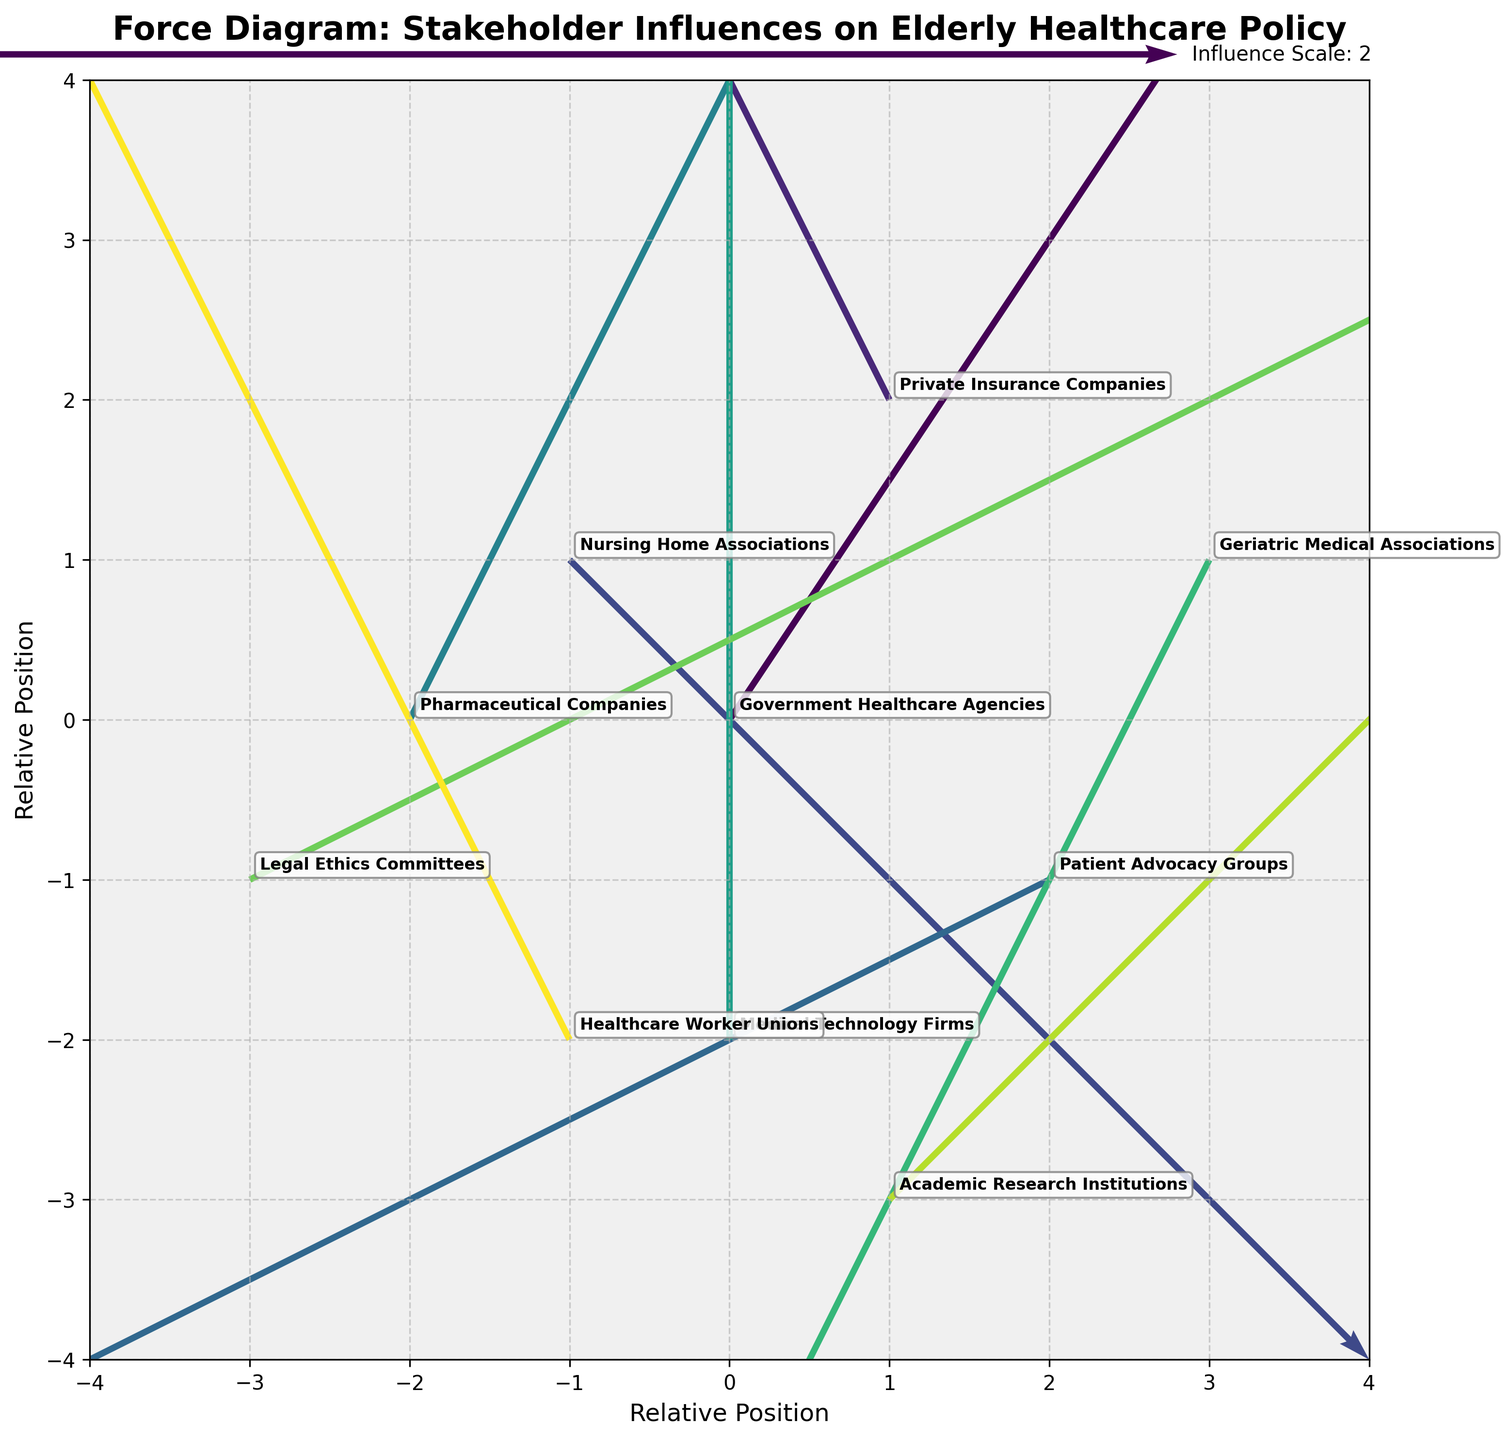What is the title of the figure? The title is displayed at the top of the figure, indicating the main theme or focus of the visualized data.
Answer: Force Diagram: Stakeholder Influences on Elderly Healthcare Policy What are the labels of the x-axis and y-axis? The x-axis and y-axis labels provide the context for interpreting the direction and magnitude of influences.
Answer: Relative Position for both axes How many stakeholders are represented in the figure? The number of unique points or arrows in the plot represents the number of stakeholders. Count the annotated labels to determine this.
Answer: 10 Which stakeholder exerts the strongest influence in the positive x-direction? The stakeholder with the largest positive value of 'u' (horizontal component) has the strongest influence in the positive x-direction.
Answer: Government Healthcare Agencies Among Medical Technology Firms and Geriatric Medical Associations, which one has a stronger influence magnitude? Compare the magnitudes of their vectors by calculating the Euclidean norm (sqrt(u^2 + v^2) for both stakeholders.
Answer: Medical Technology Firms Which stakeholder exerts an influence in the negative x and negative y directions? Identify the stakeholder by looking for a negative 'u' (horizontal) and negative 'v' (vertical) vector direction.
Answer: Patient Advocacy Groups Considering the stake of Nursing Home Associations, in which general direction is their influence oriented? Observe the vector direction (both 'u' and 'v' components) stemming from the Nursing Home Associations' point to deduce their influence direction.
Answer: Southeast What is the total number of stakeholders exerting influence in the positive y-direction? Count the number of stakeholders with positive values of 'v' (vertical component) in their vectors.
Answer: 6 Which stakeholder has the largest influence vector overall? Calculate the Euclidean norm (sqrt(u^2 + v^2)) for each stakeholder and compare to find the largest.
Answer: Medical Technology Firms Among the stakeholders located at (x=-2, y=0) and (x=1, y=2), which one exerts a stronger vertical influence? Compare the 'v' (vertical component) values of their vectors.
Answer: Private Insurance Companies 